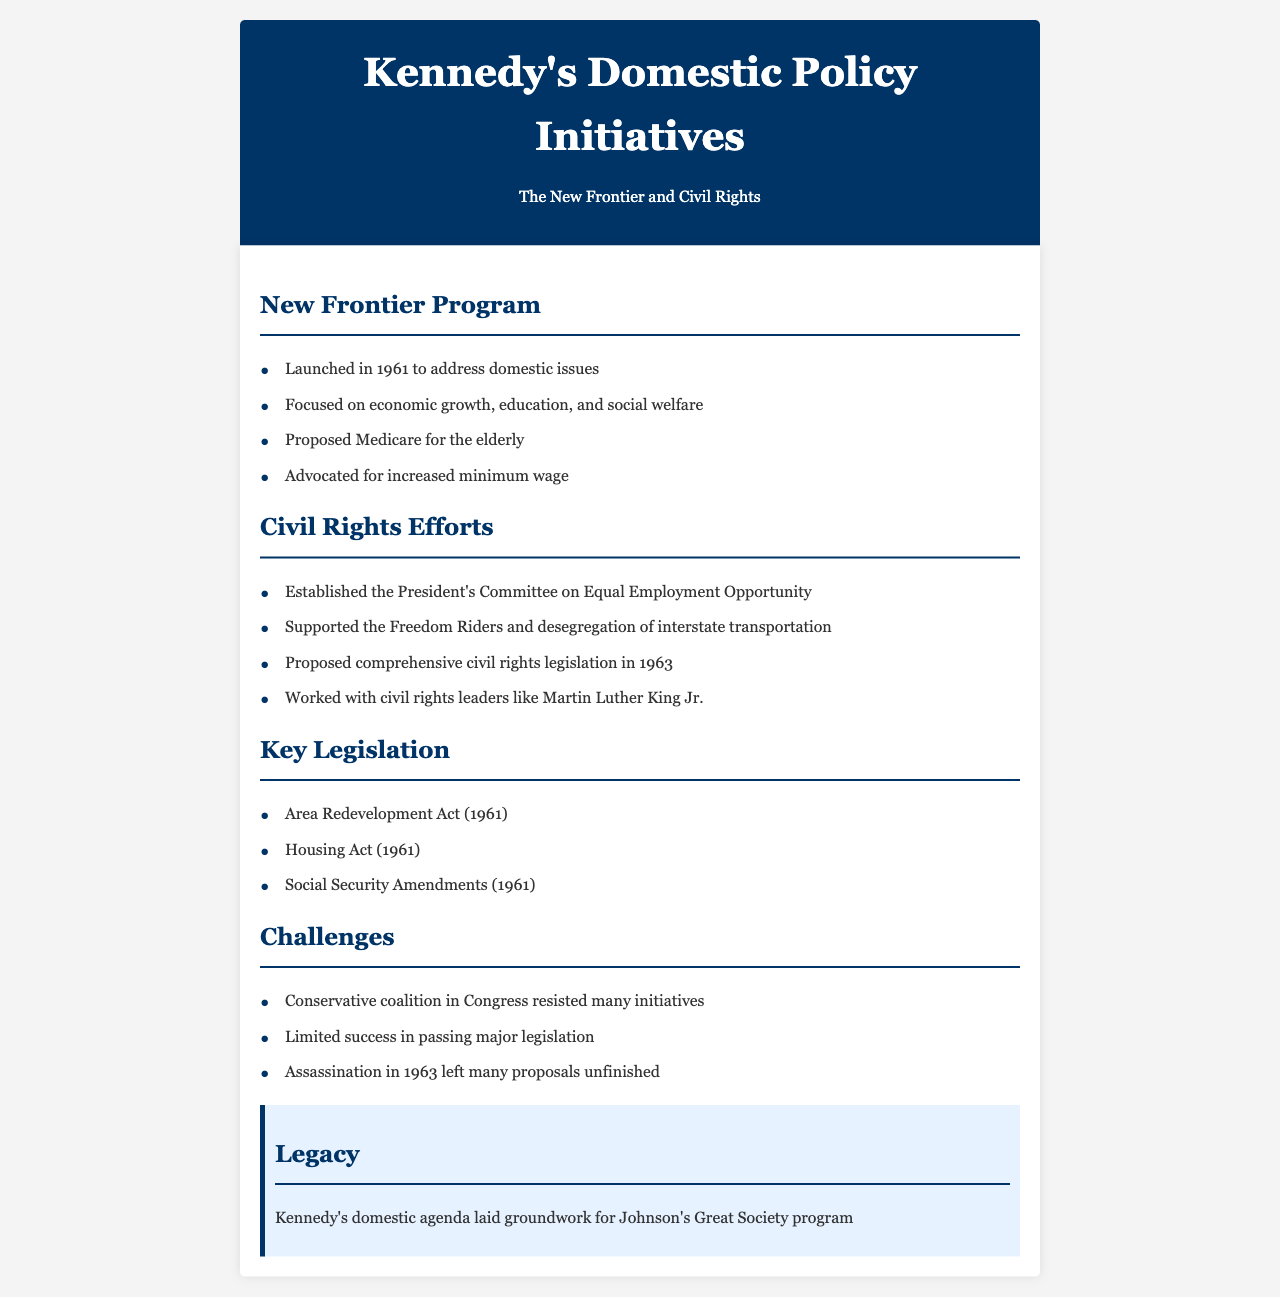What was the launch year of the New Frontier Program? The launch year of the New Frontier Program is explicitly mentioned in the document.
Answer: 1961 What focus areas were emphasized in the New Frontier Program? The focus areas of the New Frontier Program are listed in the document.
Answer: economic growth, education, and social welfare What legislation was proposed for the elderly under the New Frontier? The document specifically identifies a program aimed at the elderly.
Answer: Medicare Who worked with President Kennedy on civil rights issues? The document mentions a significant civil rights leader that Kennedy collaborated with.
Answer: Martin Luther King Jr What was one of the major challenges Kennedy faced in passing legislation? The document lists several challenges related to legislative efforts.
Answer: Conservative coalition in Congress What year was comprehensive civil rights legislation proposed? The document provides the year when this legislation was put forth.
Answer: 1963 What act addresses area redevelopment? The document includes legislation focused on area redevelopment.
Answer: Area Redevelopment Act What legacy did Kennedy's domestic agenda leave? The document summarizes the impact of Kennedy's domestic policies on future programs.
Answer: groundwork for Johnson's Great Society program 